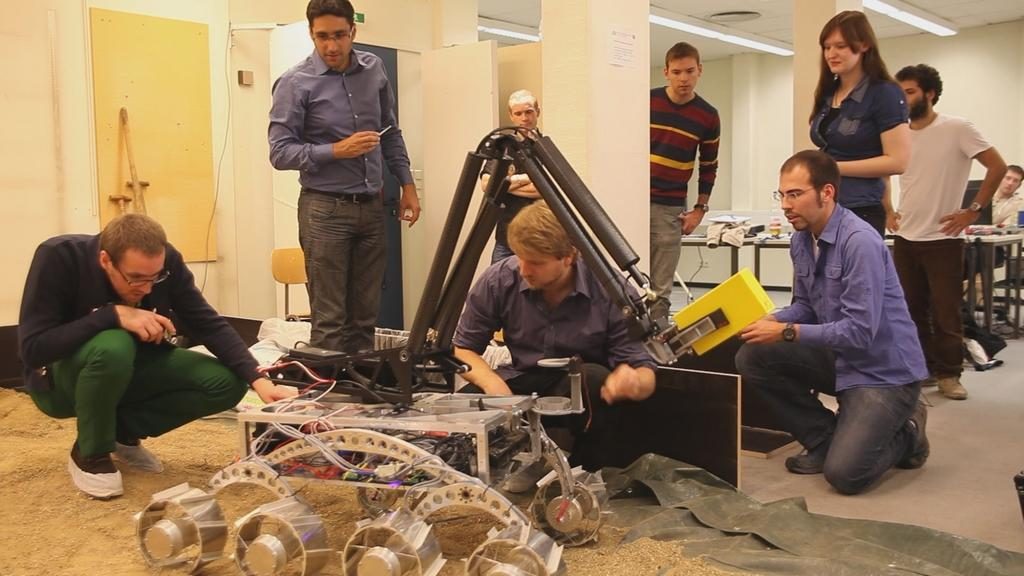How many persons are in the image? There are persons in the image. What other elements can be seen in the image besides the persons? There are objects, tables, pillars, chairs, a door, and a wall in the background of the image. Are there any light sources visible in the image? Yes, there are lights in the background of the image. What type of quartz is used to decorate the door in the image? There is no quartz present in the image, and the door is not mentioned as being decorated. Can you tell me how many members are in the band playing in the image? There is no band present in the image. 